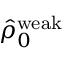Convert formula to latex. <formula><loc_0><loc_0><loc_500><loc_500>\hat { \rho } _ { 0 } ^ { w e a k }</formula> 